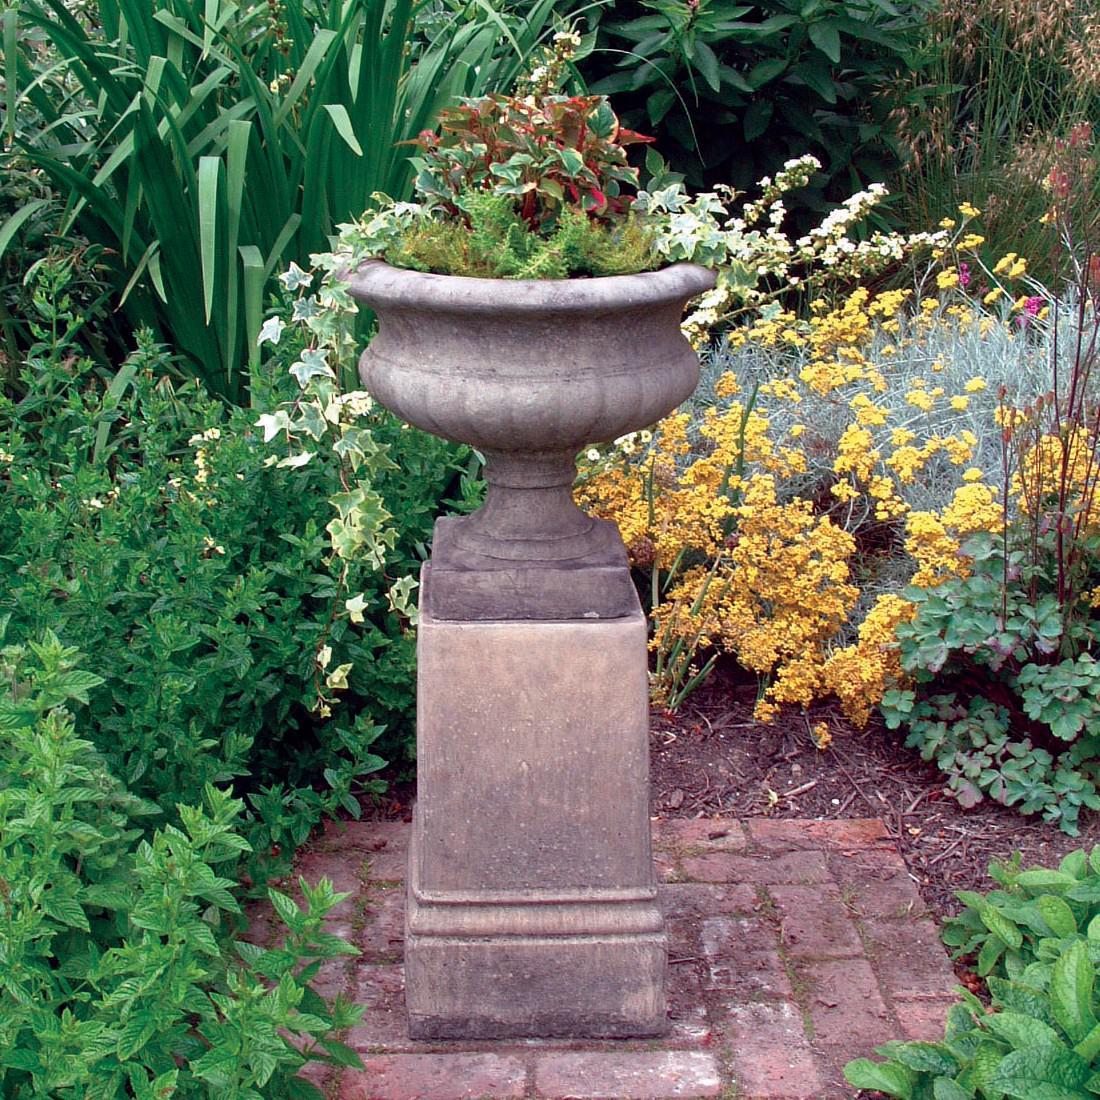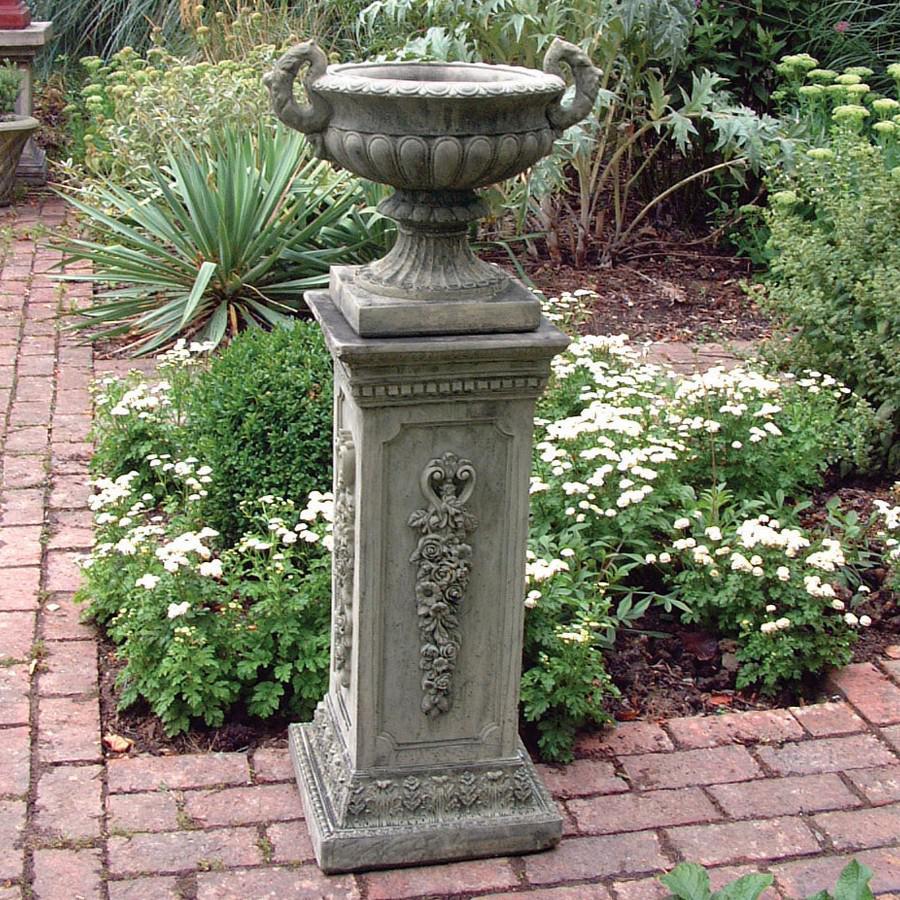The first image is the image on the left, the second image is the image on the right. Given the left and right images, does the statement "There are no flowers on the pedestal on the left." hold true? Answer yes or no. No. The first image is the image on the left, the second image is the image on the right. For the images displayed, is the sentence "An image shows a bowl-shaped stone-look planter on a column pedestal, with a plant in the bowl." factually correct? Answer yes or no. Yes. 